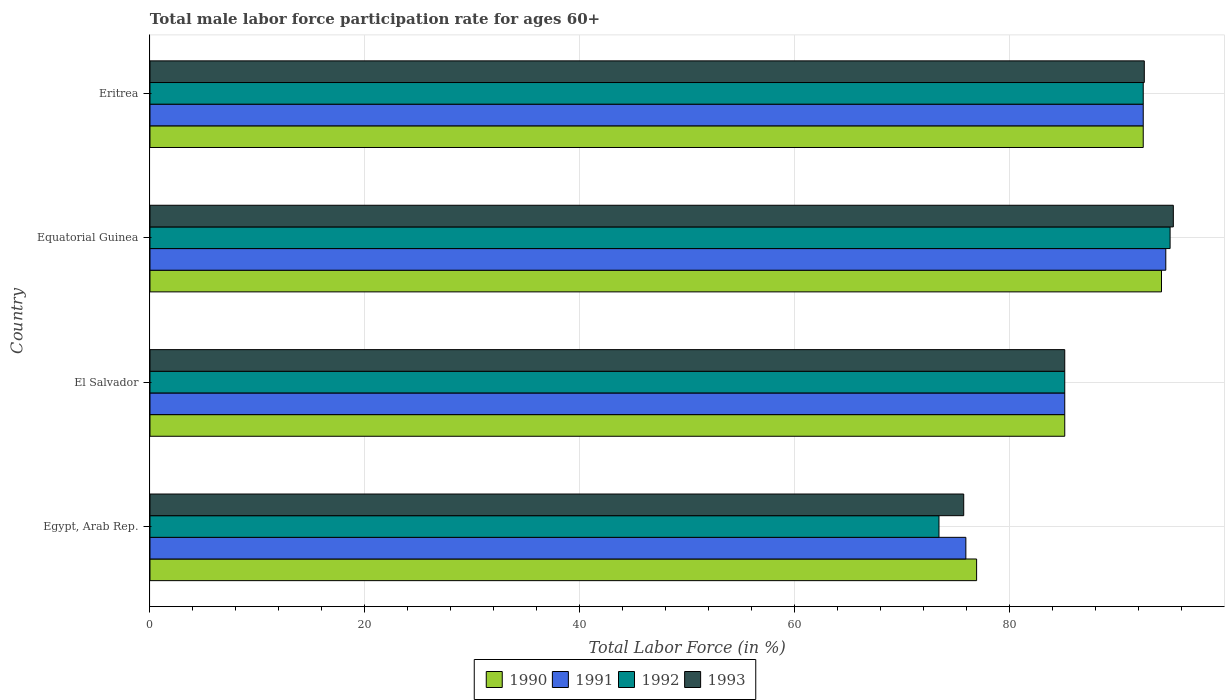Are the number of bars per tick equal to the number of legend labels?
Provide a short and direct response. Yes. Are the number of bars on each tick of the Y-axis equal?
Provide a short and direct response. Yes. What is the label of the 2nd group of bars from the top?
Offer a very short reply. Equatorial Guinea. What is the male labor force participation rate in 1992 in Eritrea?
Offer a terse response. 92.4. Across all countries, what is the maximum male labor force participation rate in 1993?
Keep it short and to the point. 95.2. Across all countries, what is the minimum male labor force participation rate in 1990?
Offer a very short reply. 76.9. In which country was the male labor force participation rate in 1990 maximum?
Provide a succinct answer. Equatorial Guinea. In which country was the male labor force participation rate in 1993 minimum?
Offer a very short reply. Egypt, Arab Rep. What is the total male labor force participation rate in 1993 in the graph?
Offer a terse response. 348.5. What is the difference between the male labor force participation rate in 1991 in Equatorial Guinea and that in Eritrea?
Keep it short and to the point. 2.1. What is the difference between the male labor force participation rate in 1993 in Eritrea and the male labor force participation rate in 1992 in Egypt, Arab Rep.?
Offer a terse response. 19.1. What is the average male labor force participation rate in 1993 per country?
Your response must be concise. 87.12. What is the difference between the male labor force participation rate in 1992 and male labor force participation rate in 1993 in Egypt, Arab Rep.?
Your response must be concise. -2.3. What is the ratio of the male labor force participation rate in 1993 in Egypt, Arab Rep. to that in El Salvador?
Your answer should be compact. 0.89. Is the male labor force participation rate in 1990 in El Salvador less than that in Eritrea?
Your answer should be very brief. Yes. What is the difference between the highest and the second highest male labor force participation rate in 1991?
Your response must be concise. 2.1. What is the difference between the highest and the lowest male labor force participation rate in 1990?
Your answer should be very brief. 17.2. Is the sum of the male labor force participation rate in 1992 in Egypt, Arab Rep. and El Salvador greater than the maximum male labor force participation rate in 1991 across all countries?
Keep it short and to the point. Yes. Is it the case that in every country, the sum of the male labor force participation rate in 1993 and male labor force participation rate in 1990 is greater than the male labor force participation rate in 1992?
Keep it short and to the point. Yes. How many bars are there?
Your answer should be very brief. 16. Are all the bars in the graph horizontal?
Your response must be concise. Yes. Does the graph contain any zero values?
Make the answer very short. No. Where does the legend appear in the graph?
Offer a terse response. Bottom center. How many legend labels are there?
Ensure brevity in your answer.  4. What is the title of the graph?
Give a very brief answer. Total male labor force participation rate for ages 60+. Does "1967" appear as one of the legend labels in the graph?
Offer a very short reply. No. What is the label or title of the X-axis?
Make the answer very short. Total Labor Force (in %). What is the label or title of the Y-axis?
Your answer should be compact. Country. What is the Total Labor Force (in %) of 1990 in Egypt, Arab Rep.?
Offer a terse response. 76.9. What is the Total Labor Force (in %) of 1991 in Egypt, Arab Rep.?
Your answer should be very brief. 75.9. What is the Total Labor Force (in %) in 1992 in Egypt, Arab Rep.?
Provide a succinct answer. 73.4. What is the Total Labor Force (in %) in 1993 in Egypt, Arab Rep.?
Keep it short and to the point. 75.7. What is the Total Labor Force (in %) in 1990 in El Salvador?
Your answer should be very brief. 85.1. What is the Total Labor Force (in %) of 1991 in El Salvador?
Ensure brevity in your answer.  85.1. What is the Total Labor Force (in %) in 1992 in El Salvador?
Provide a short and direct response. 85.1. What is the Total Labor Force (in %) of 1993 in El Salvador?
Offer a very short reply. 85.1. What is the Total Labor Force (in %) of 1990 in Equatorial Guinea?
Your answer should be very brief. 94.1. What is the Total Labor Force (in %) of 1991 in Equatorial Guinea?
Offer a very short reply. 94.5. What is the Total Labor Force (in %) of 1992 in Equatorial Guinea?
Make the answer very short. 94.9. What is the Total Labor Force (in %) of 1993 in Equatorial Guinea?
Keep it short and to the point. 95.2. What is the Total Labor Force (in %) of 1990 in Eritrea?
Offer a very short reply. 92.4. What is the Total Labor Force (in %) in 1991 in Eritrea?
Offer a terse response. 92.4. What is the Total Labor Force (in %) of 1992 in Eritrea?
Keep it short and to the point. 92.4. What is the Total Labor Force (in %) of 1993 in Eritrea?
Your response must be concise. 92.5. Across all countries, what is the maximum Total Labor Force (in %) in 1990?
Provide a succinct answer. 94.1. Across all countries, what is the maximum Total Labor Force (in %) in 1991?
Offer a very short reply. 94.5. Across all countries, what is the maximum Total Labor Force (in %) in 1992?
Your answer should be very brief. 94.9. Across all countries, what is the maximum Total Labor Force (in %) of 1993?
Keep it short and to the point. 95.2. Across all countries, what is the minimum Total Labor Force (in %) of 1990?
Provide a succinct answer. 76.9. Across all countries, what is the minimum Total Labor Force (in %) of 1991?
Give a very brief answer. 75.9. Across all countries, what is the minimum Total Labor Force (in %) in 1992?
Offer a very short reply. 73.4. Across all countries, what is the minimum Total Labor Force (in %) in 1993?
Make the answer very short. 75.7. What is the total Total Labor Force (in %) of 1990 in the graph?
Your answer should be compact. 348.5. What is the total Total Labor Force (in %) of 1991 in the graph?
Offer a very short reply. 347.9. What is the total Total Labor Force (in %) in 1992 in the graph?
Your response must be concise. 345.8. What is the total Total Labor Force (in %) in 1993 in the graph?
Your response must be concise. 348.5. What is the difference between the Total Labor Force (in %) of 1991 in Egypt, Arab Rep. and that in El Salvador?
Offer a very short reply. -9.2. What is the difference between the Total Labor Force (in %) of 1990 in Egypt, Arab Rep. and that in Equatorial Guinea?
Provide a short and direct response. -17.2. What is the difference between the Total Labor Force (in %) of 1991 in Egypt, Arab Rep. and that in Equatorial Guinea?
Make the answer very short. -18.6. What is the difference between the Total Labor Force (in %) of 1992 in Egypt, Arab Rep. and that in Equatorial Guinea?
Provide a succinct answer. -21.5. What is the difference between the Total Labor Force (in %) of 1993 in Egypt, Arab Rep. and that in Equatorial Guinea?
Keep it short and to the point. -19.5. What is the difference between the Total Labor Force (in %) of 1990 in Egypt, Arab Rep. and that in Eritrea?
Make the answer very short. -15.5. What is the difference between the Total Labor Force (in %) in 1991 in Egypt, Arab Rep. and that in Eritrea?
Offer a very short reply. -16.5. What is the difference between the Total Labor Force (in %) in 1992 in Egypt, Arab Rep. and that in Eritrea?
Your answer should be very brief. -19. What is the difference between the Total Labor Force (in %) in 1993 in Egypt, Arab Rep. and that in Eritrea?
Your answer should be very brief. -16.8. What is the difference between the Total Labor Force (in %) in 1990 in El Salvador and that in Equatorial Guinea?
Offer a very short reply. -9. What is the difference between the Total Labor Force (in %) of 1993 in El Salvador and that in Equatorial Guinea?
Your answer should be compact. -10.1. What is the difference between the Total Labor Force (in %) of 1991 in El Salvador and that in Eritrea?
Offer a terse response. -7.3. What is the difference between the Total Labor Force (in %) of 1992 in El Salvador and that in Eritrea?
Your answer should be compact. -7.3. What is the difference between the Total Labor Force (in %) in 1990 in Egypt, Arab Rep. and the Total Labor Force (in %) in 1992 in El Salvador?
Offer a terse response. -8.2. What is the difference between the Total Labor Force (in %) in 1990 in Egypt, Arab Rep. and the Total Labor Force (in %) in 1993 in El Salvador?
Make the answer very short. -8.2. What is the difference between the Total Labor Force (in %) of 1992 in Egypt, Arab Rep. and the Total Labor Force (in %) of 1993 in El Salvador?
Provide a short and direct response. -11.7. What is the difference between the Total Labor Force (in %) of 1990 in Egypt, Arab Rep. and the Total Labor Force (in %) of 1991 in Equatorial Guinea?
Make the answer very short. -17.6. What is the difference between the Total Labor Force (in %) in 1990 in Egypt, Arab Rep. and the Total Labor Force (in %) in 1992 in Equatorial Guinea?
Keep it short and to the point. -18. What is the difference between the Total Labor Force (in %) in 1990 in Egypt, Arab Rep. and the Total Labor Force (in %) in 1993 in Equatorial Guinea?
Make the answer very short. -18.3. What is the difference between the Total Labor Force (in %) in 1991 in Egypt, Arab Rep. and the Total Labor Force (in %) in 1992 in Equatorial Guinea?
Keep it short and to the point. -19. What is the difference between the Total Labor Force (in %) in 1991 in Egypt, Arab Rep. and the Total Labor Force (in %) in 1993 in Equatorial Guinea?
Keep it short and to the point. -19.3. What is the difference between the Total Labor Force (in %) of 1992 in Egypt, Arab Rep. and the Total Labor Force (in %) of 1993 in Equatorial Guinea?
Give a very brief answer. -21.8. What is the difference between the Total Labor Force (in %) in 1990 in Egypt, Arab Rep. and the Total Labor Force (in %) in 1991 in Eritrea?
Provide a succinct answer. -15.5. What is the difference between the Total Labor Force (in %) of 1990 in Egypt, Arab Rep. and the Total Labor Force (in %) of 1992 in Eritrea?
Keep it short and to the point. -15.5. What is the difference between the Total Labor Force (in %) of 1990 in Egypt, Arab Rep. and the Total Labor Force (in %) of 1993 in Eritrea?
Ensure brevity in your answer.  -15.6. What is the difference between the Total Labor Force (in %) in 1991 in Egypt, Arab Rep. and the Total Labor Force (in %) in 1992 in Eritrea?
Make the answer very short. -16.5. What is the difference between the Total Labor Force (in %) in 1991 in Egypt, Arab Rep. and the Total Labor Force (in %) in 1993 in Eritrea?
Keep it short and to the point. -16.6. What is the difference between the Total Labor Force (in %) of 1992 in Egypt, Arab Rep. and the Total Labor Force (in %) of 1993 in Eritrea?
Ensure brevity in your answer.  -19.1. What is the difference between the Total Labor Force (in %) of 1990 in El Salvador and the Total Labor Force (in %) of 1991 in Equatorial Guinea?
Offer a very short reply. -9.4. What is the difference between the Total Labor Force (in %) of 1990 in El Salvador and the Total Labor Force (in %) of 1992 in Equatorial Guinea?
Your answer should be compact. -9.8. What is the difference between the Total Labor Force (in %) in 1991 in El Salvador and the Total Labor Force (in %) in 1992 in Equatorial Guinea?
Provide a succinct answer. -9.8. What is the difference between the Total Labor Force (in %) in 1992 in El Salvador and the Total Labor Force (in %) in 1993 in Equatorial Guinea?
Ensure brevity in your answer.  -10.1. What is the difference between the Total Labor Force (in %) of 1990 in El Salvador and the Total Labor Force (in %) of 1991 in Eritrea?
Offer a terse response. -7.3. What is the difference between the Total Labor Force (in %) in 1990 in El Salvador and the Total Labor Force (in %) in 1992 in Eritrea?
Provide a succinct answer. -7.3. What is the difference between the Total Labor Force (in %) in 1990 in El Salvador and the Total Labor Force (in %) in 1993 in Eritrea?
Make the answer very short. -7.4. What is the difference between the Total Labor Force (in %) in 1991 in El Salvador and the Total Labor Force (in %) in 1992 in Eritrea?
Provide a short and direct response. -7.3. What is the difference between the Total Labor Force (in %) of 1990 in Equatorial Guinea and the Total Labor Force (in %) of 1991 in Eritrea?
Provide a short and direct response. 1.7. What is the difference between the Total Labor Force (in %) in 1992 in Equatorial Guinea and the Total Labor Force (in %) in 1993 in Eritrea?
Your answer should be very brief. 2.4. What is the average Total Labor Force (in %) in 1990 per country?
Provide a succinct answer. 87.12. What is the average Total Labor Force (in %) of 1991 per country?
Give a very brief answer. 86.97. What is the average Total Labor Force (in %) in 1992 per country?
Provide a short and direct response. 86.45. What is the average Total Labor Force (in %) of 1993 per country?
Your answer should be compact. 87.12. What is the difference between the Total Labor Force (in %) of 1990 and Total Labor Force (in %) of 1992 in Egypt, Arab Rep.?
Your response must be concise. 3.5. What is the difference between the Total Labor Force (in %) in 1991 and Total Labor Force (in %) in 1993 in Egypt, Arab Rep.?
Provide a short and direct response. 0.2. What is the difference between the Total Labor Force (in %) in 1992 and Total Labor Force (in %) in 1993 in Egypt, Arab Rep.?
Give a very brief answer. -2.3. What is the difference between the Total Labor Force (in %) of 1990 and Total Labor Force (in %) of 1991 in El Salvador?
Your answer should be compact. 0. What is the difference between the Total Labor Force (in %) of 1991 and Total Labor Force (in %) of 1992 in El Salvador?
Keep it short and to the point. 0. What is the difference between the Total Labor Force (in %) of 1991 and Total Labor Force (in %) of 1993 in El Salvador?
Offer a very short reply. 0. What is the difference between the Total Labor Force (in %) of 1992 and Total Labor Force (in %) of 1993 in El Salvador?
Offer a very short reply. 0. What is the difference between the Total Labor Force (in %) of 1990 and Total Labor Force (in %) of 1992 in Equatorial Guinea?
Keep it short and to the point. -0.8. What is the difference between the Total Labor Force (in %) of 1992 and Total Labor Force (in %) of 1993 in Equatorial Guinea?
Offer a very short reply. -0.3. What is the difference between the Total Labor Force (in %) in 1990 and Total Labor Force (in %) in 1993 in Eritrea?
Keep it short and to the point. -0.1. What is the difference between the Total Labor Force (in %) of 1991 and Total Labor Force (in %) of 1992 in Eritrea?
Ensure brevity in your answer.  0. What is the difference between the Total Labor Force (in %) of 1991 and Total Labor Force (in %) of 1993 in Eritrea?
Offer a very short reply. -0.1. What is the ratio of the Total Labor Force (in %) in 1990 in Egypt, Arab Rep. to that in El Salvador?
Keep it short and to the point. 0.9. What is the ratio of the Total Labor Force (in %) in 1991 in Egypt, Arab Rep. to that in El Salvador?
Keep it short and to the point. 0.89. What is the ratio of the Total Labor Force (in %) of 1992 in Egypt, Arab Rep. to that in El Salvador?
Your response must be concise. 0.86. What is the ratio of the Total Labor Force (in %) of 1993 in Egypt, Arab Rep. to that in El Salvador?
Your answer should be compact. 0.89. What is the ratio of the Total Labor Force (in %) of 1990 in Egypt, Arab Rep. to that in Equatorial Guinea?
Provide a succinct answer. 0.82. What is the ratio of the Total Labor Force (in %) of 1991 in Egypt, Arab Rep. to that in Equatorial Guinea?
Make the answer very short. 0.8. What is the ratio of the Total Labor Force (in %) of 1992 in Egypt, Arab Rep. to that in Equatorial Guinea?
Provide a succinct answer. 0.77. What is the ratio of the Total Labor Force (in %) in 1993 in Egypt, Arab Rep. to that in Equatorial Guinea?
Make the answer very short. 0.8. What is the ratio of the Total Labor Force (in %) in 1990 in Egypt, Arab Rep. to that in Eritrea?
Offer a very short reply. 0.83. What is the ratio of the Total Labor Force (in %) of 1991 in Egypt, Arab Rep. to that in Eritrea?
Provide a short and direct response. 0.82. What is the ratio of the Total Labor Force (in %) of 1992 in Egypt, Arab Rep. to that in Eritrea?
Ensure brevity in your answer.  0.79. What is the ratio of the Total Labor Force (in %) in 1993 in Egypt, Arab Rep. to that in Eritrea?
Offer a very short reply. 0.82. What is the ratio of the Total Labor Force (in %) of 1990 in El Salvador to that in Equatorial Guinea?
Your response must be concise. 0.9. What is the ratio of the Total Labor Force (in %) in 1991 in El Salvador to that in Equatorial Guinea?
Your answer should be very brief. 0.9. What is the ratio of the Total Labor Force (in %) of 1992 in El Salvador to that in Equatorial Guinea?
Give a very brief answer. 0.9. What is the ratio of the Total Labor Force (in %) of 1993 in El Salvador to that in Equatorial Guinea?
Your response must be concise. 0.89. What is the ratio of the Total Labor Force (in %) in 1990 in El Salvador to that in Eritrea?
Your response must be concise. 0.92. What is the ratio of the Total Labor Force (in %) in 1991 in El Salvador to that in Eritrea?
Offer a very short reply. 0.92. What is the ratio of the Total Labor Force (in %) in 1992 in El Salvador to that in Eritrea?
Your response must be concise. 0.92. What is the ratio of the Total Labor Force (in %) of 1990 in Equatorial Guinea to that in Eritrea?
Offer a terse response. 1.02. What is the ratio of the Total Labor Force (in %) of 1991 in Equatorial Guinea to that in Eritrea?
Give a very brief answer. 1.02. What is the ratio of the Total Labor Force (in %) in 1992 in Equatorial Guinea to that in Eritrea?
Your answer should be very brief. 1.03. What is the ratio of the Total Labor Force (in %) in 1993 in Equatorial Guinea to that in Eritrea?
Make the answer very short. 1.03. What is the difference between the highest and the second highest Total Labor Force (in %) in 1991?
Ensure brevity in your answer.  2.1. What is the difference between the highest and the second highest Total Labor Force (in %) of 1993?
Provide a short and direct response. 2.7. What is the difference between the highest and the lowest Total Labor Force (in %) in 1990?
Provide a short and direct response. 17.2. 